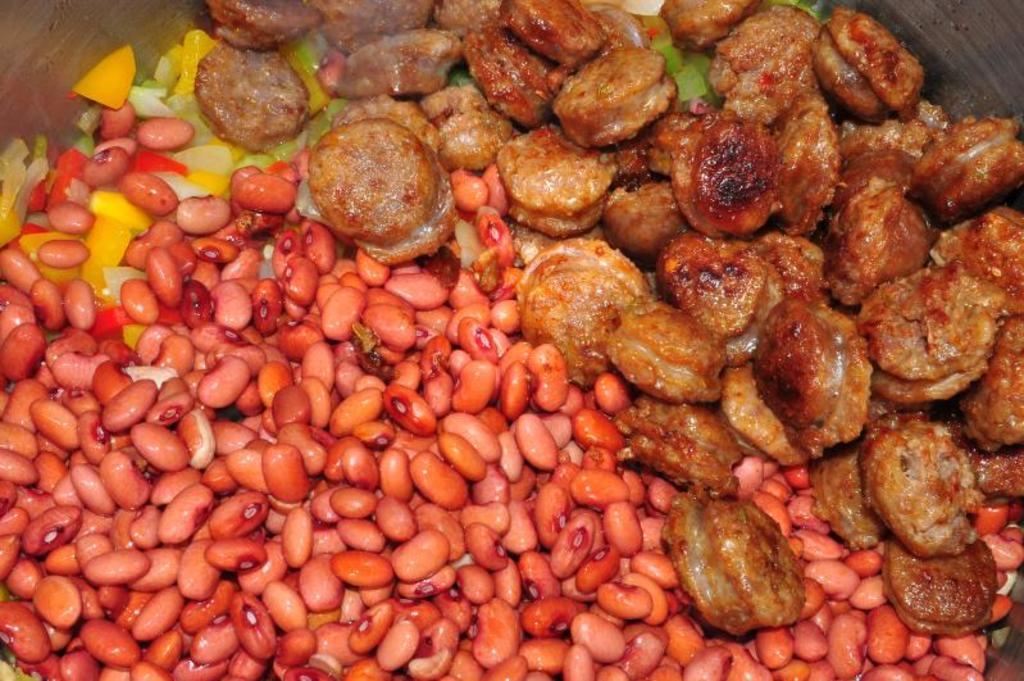What type of food is present in the image? There are kidney beans in the image. What colors can be observed in the food items in the image? The food items in the image have brown and yellow colors. What type of branch can be seen in the image? There is no branch present in the image; it only features kidney beans and food items in brown and yellow colors. 